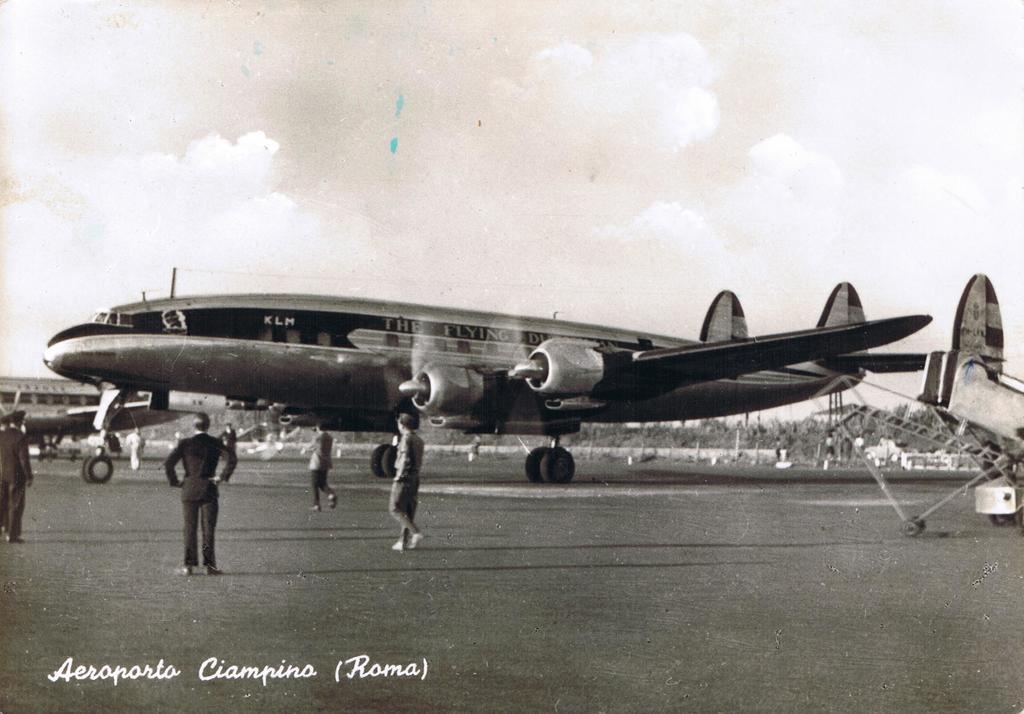What place is mentioned?
Your answer should be very brief. Roma. What is written on the plane?
Your answer should be compact. The flying. 